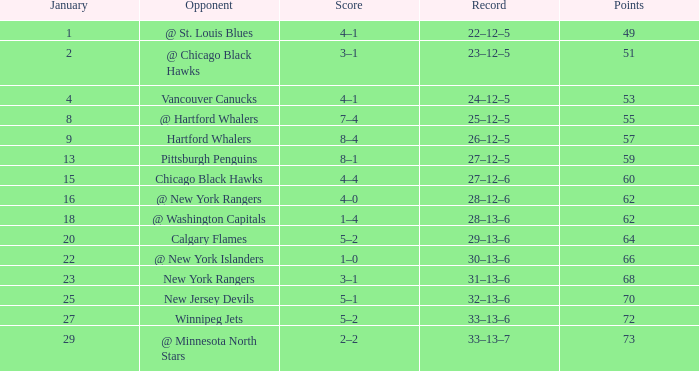Give me the full table as a dictionary. {'header': ['January', 'Opponent', 'Score', 'Record', 'Points'], 'rows': [['1', '@ St. Louis Blues', '4–1', '22–12–5', '49'], ['2', '@ Chicago Black Hawks', '3–1', '23–12–5', '51'], ['4', 'Vancouver Canucks', '4–1', '24–12–5', '53'], ['8', '@ Hartford Whalers', '7–4', '25–12–5', '55'], ['9', 'Hartford Whalers', '8–4', '26–12–5', '57'], ['13', 'Pittsburgh Penguins', '8–1', '27–12–5', '59'], ['15', 'Chicago Black Hawks', '4–4', '27–12–6', '60'], ['16', '@ New York Rangers', '4–0', '28–12–6', '62'], ['18', '@ Washington Capitals', '1–4', '28–13–6', '62'], ['20', 'Calgary Flames', '5–2', '29–13–6', '64'], ['22', '@ New York Islanders', '1–0', '30–13–6', '66'], ['23', 'New York Rangers', '3–1', '31–13–6', '68'], ['25', 'New Jersey Devils', '5–1', '32–13–6', '70'], ['27', 'Winnipeg Jets', '5–2', '33–13–6', '72'], ['29', '@ Minnesota North Stars', '2–2', '33–13–7', '73']]} Which points is the lowest one having a score of 1–4, and a january below 18? None. 